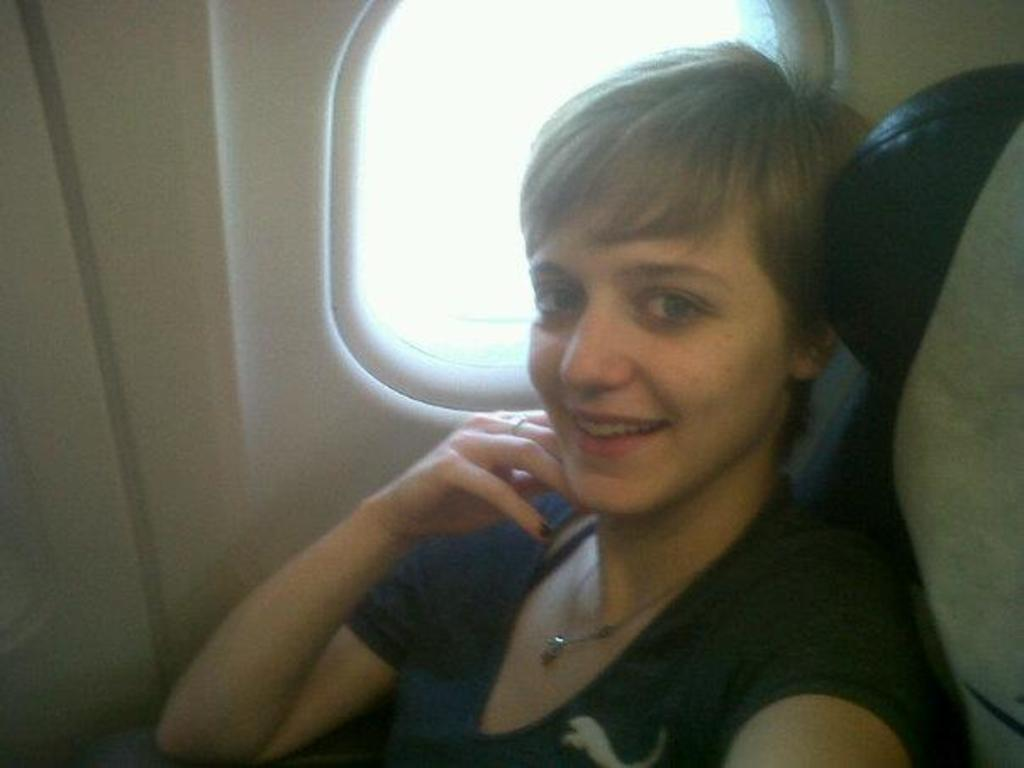Who is the main subject in the image? There is a woman in the image. What is the woman wearing? The woman is wearing a black dress. Where is the woman located in the image? The woman is sitting in an airplane. What can be seen in the background of the image? There is a window visible in the background of the image. What type of jar is visible on the woman's tongue in the image? There is no jar or tongue visible in the image; it only features a woman sitting in an airplane. 